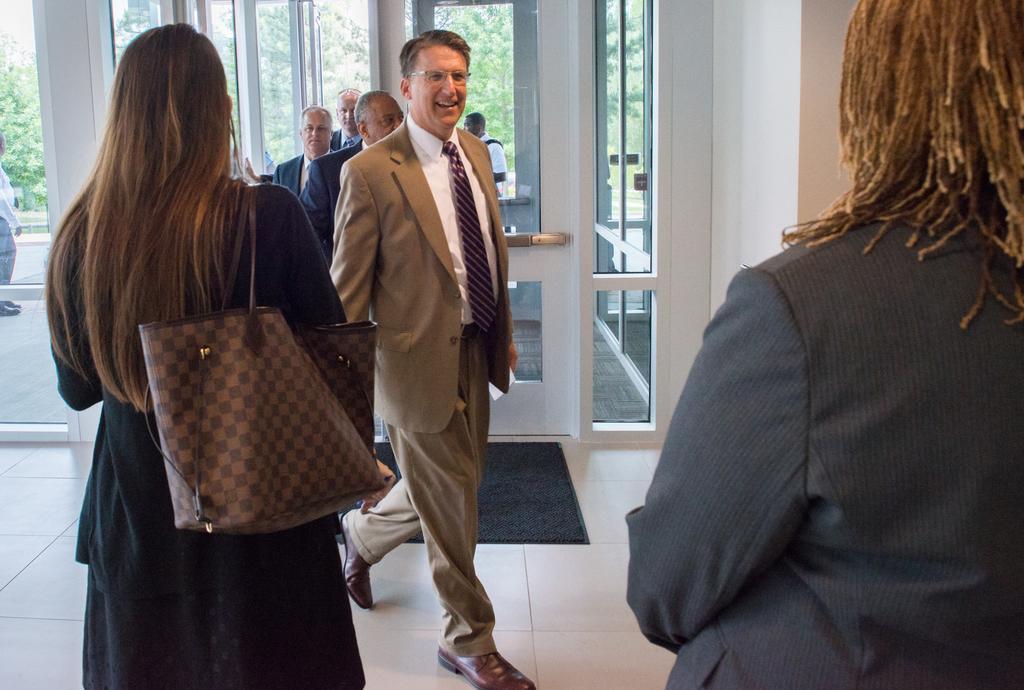Please provide a concise description of this image. In this picture we can see persons standing and walking on the floor. This is a doormat. Through glass doors we can see outside view, trees and persons. 